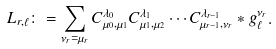<formula> <loc_0><loc_0><loc_500><loc_500>L _ { r , \ell } \colon = \sum _ { \nu _ { r } = \mu _ { r } } C _ { \mu _ { 0 } , \mu _ { 1 } } ^ { \lambda _ { 0 } } C _ { \mu _ { 1 } , \mu _ { 2 } } ^ { \lambda _ { 1 } } \cdots C _ { \mu _ { r - 1 } , \nu _ { r } } ^ { \lambda _ { r - 1 } } * g _ { \ell } ^ { \nu _ { r } } .</formula> 